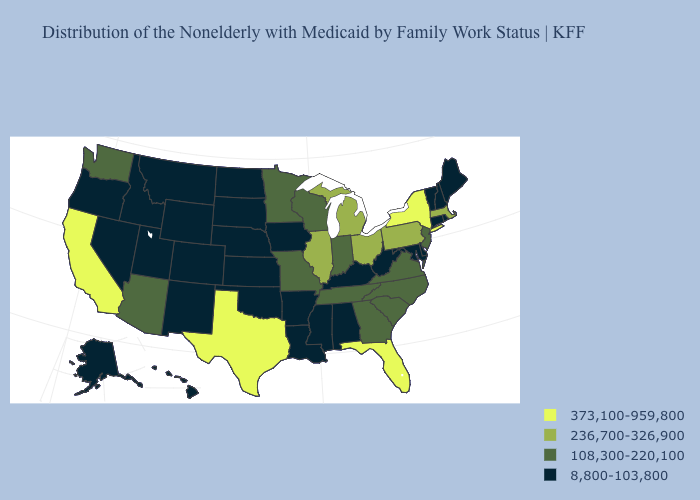What is the value of Idaho?
Be succinct. 8,800-103,800. Name the states that have a value in the range 108,300-220,100?
Concise answer only. Arizona, Georgia, Indiana, Minnesota, Missouri, New Jersey, North Carolina, South Carolina, Tennessee, Virginia, Washington, Wisconsin. Name the states that have a value in the range 236,700-326,900?
Answer briefly. Illinois, Massachusetts, Michigan, Ohio, Pennsylvania. What is the lowest value in states that border Kansas?
Give a very brief answer. 8,800-103,800. What is the value of New Jersey?
Concise answer only. 108,300-220,100. Name the states that have a value in the range 8,800-103,800?
Give a very brief answer. Alabama, Alaska, Arkansas, Colorado, Connecticut, Delaware, Hawaii, Idaho, Iowa, Kansas, Kentucky, Louisiana, Maine, Maryland, Mississippi, Montana, Nebraska, Nevada, New Hampshire, New Mexico, North Dakota, Oklahoma, Oregon, Rhode Island, South Dakota, Utah, Vermont, West Virginia, Wyoming. What is the highest value in the USA?
Quick response, please. 373,100-959,800. What is the lowest value in the South?
Concise answer only. 8,800-103,800. Does Wisconsin have the same value as Minnesota?
Quick response, please. Yes. What is the value of West Virginia?
Short answer required. 8,800-103,800. Among the states that border Mississippi , does Tennessee have the highest value?
Quick response, please. Yes. How many symbols are there in the legend?
Answer briefly. 4. Does Pennsylvania have a higher value than Illinois?
Give a very brief answer. No. What is the value of South Carolina?
Write a very short answer. 108,300-220,100. Which states have the lowest value in the USA?
Write a very short answer. Alabama, Alaska, Arkansas, Colorado, Connecticut, Delaware, Hawaii, Idaho, Iowa, Kansas, Kentucky, Louisiana, Maine, Maryland, Mississippi, Montana, Nebraska, Nevada, New Hampshire, New Mexico, North Dakota, Oklahoma, Oregon, Rhode Island, South Dakota, Utah, Vermont, West Virginia, Wyoming. 